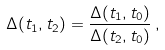Convert formula to latex. <formula><loc_0><loc_0><loc_500><loc_500>\Delta ( t _ { 1 } , t _ { 2 } ) = \frac { \Delta ( t _ { 1 } , t _ { 0 } ) } { \Delta ( t _ { 2 } , t _ { 0 } ) } \, ,</formula> 